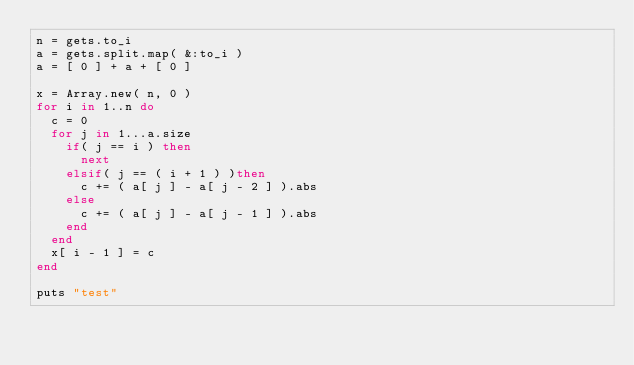<code> <loc_0><loc_0><loc_500><loc_500><_Ruby_>n = gets.to_i
a = gets.split.map( &:to_i )
a = [ 0 ] + a + [ 0 ]

x = Array.new( n, 0 )
for i in 1..n do
  c = 0
  for j in 1...a.size
    if( j == i ) then
      next
    elsif( j == ( i + 1 ) )then
      c += ( a[ j ] - a[ j - 2 ] ).abs
    else
      c += ( a[ j ] - a[ j - 1 ] ).abs
    end
  end
  x[ i - 1 ] = c
end

puts "test"</code> 